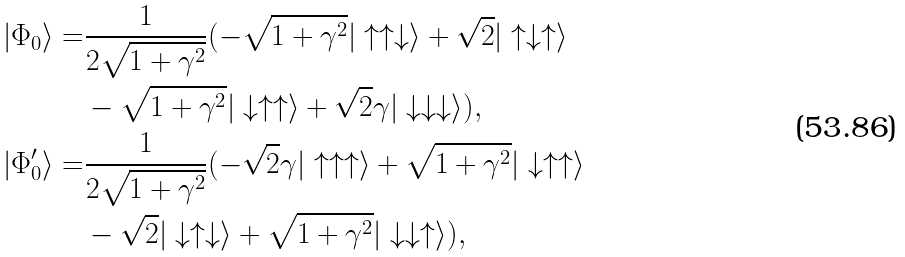<formula> <loc_0><loc_0><loc_500><loc_500>| \Phi _ { 0 } \rangle = & \frac { 1 } { 2 \sqrt { 1 + \gamma ^ { 2 } } } ( - \sqrt { 1 + \gamma ^ { 2 } } | \uparrow \uparrow \downarrow \rangle + \sqrt { 2 } | \uparrow \downarrow \uparrow \rangle \\ & - \sqrt { 1 + \gamma ^ { 2 } } | \downarrow \uparrow \uparrow \rangle + \sqrt { 2 } \gamma | \downarrow \downarrow \downarrow \rangle ) , \\ | \Phi ^ { \prime } _ { 0 } \rangle = & \frac { 1 } { 2 \sqrt { 1 + \gamma ^ { 2 } } } ( - \sqrt { 2 } \gamma | \uparrow \uparrow \uparrow \rangle + \sqrt { 1 + \gamma ^ { 2 } } | \downarrow \uparrow \uparrow \rangle \\ & - \sqrt { 2 } | \downarrow \uparrow \downarrow \rangle + \sqrt { 1 + \gamma ^ { 2 } } | \downarrow \downarrow \uparrow \rangle ) ,</formula> 